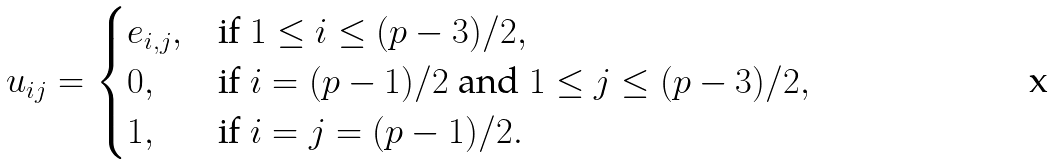Convert formula to latex. <formula><loc_0><loc_0><loc_500><loc_500>u _ { i j } = \begin{cases} e _ { i , j } , & \text {if } 1 \leq i \leq ( p - 3 ) / 2 , \\ 0 , & \text {if } i = ( p - 1 ) / 2 \text { and } 1 \leq j \leq ( p - 3 ) / 2 , \\ 1 , & \text {if } i = j = ( p - 1 ) / 2 . \end{cases}</formula> 